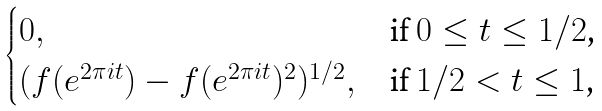<formula> <loc_0><loc_0><loc_500><loc_500>\begin{cases} 0 , & \text {if $0\leq t\leq 1/2$,} \\ ( f ( e ^ { 2 \pi i t } ) - f ( e ^ { 2 \pi i t } ) ^ { 2 } ) ^ { 1 / 2 } , & \text {if $1/2<t\leq 1$,} \end{cases}</formula> 